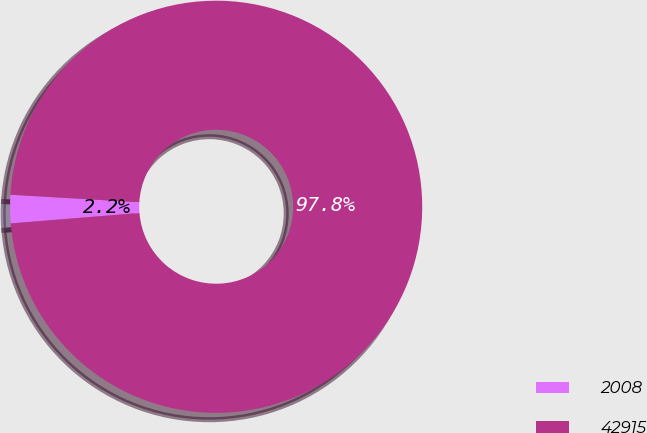Convert chart to OTSL. <chart><loc_0><loc_0><loc_500><loc_500><pie_chart><fcel>2008<fcel>42915<nl><fcel>2.22%<fcel>97.78%<nl></chart> 